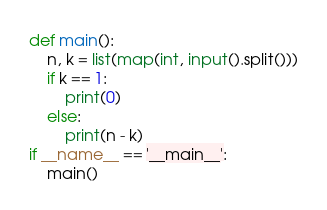Convert code to text. <code><loc_0><loc_0><loc_500><loc_500><_Python_>def main():
    n, k = list(map(int, input().split()))
    if k == 1:
        print(0)
    else:
        print(n - k)
if __name__ == '__main__':
    main()
</code> 